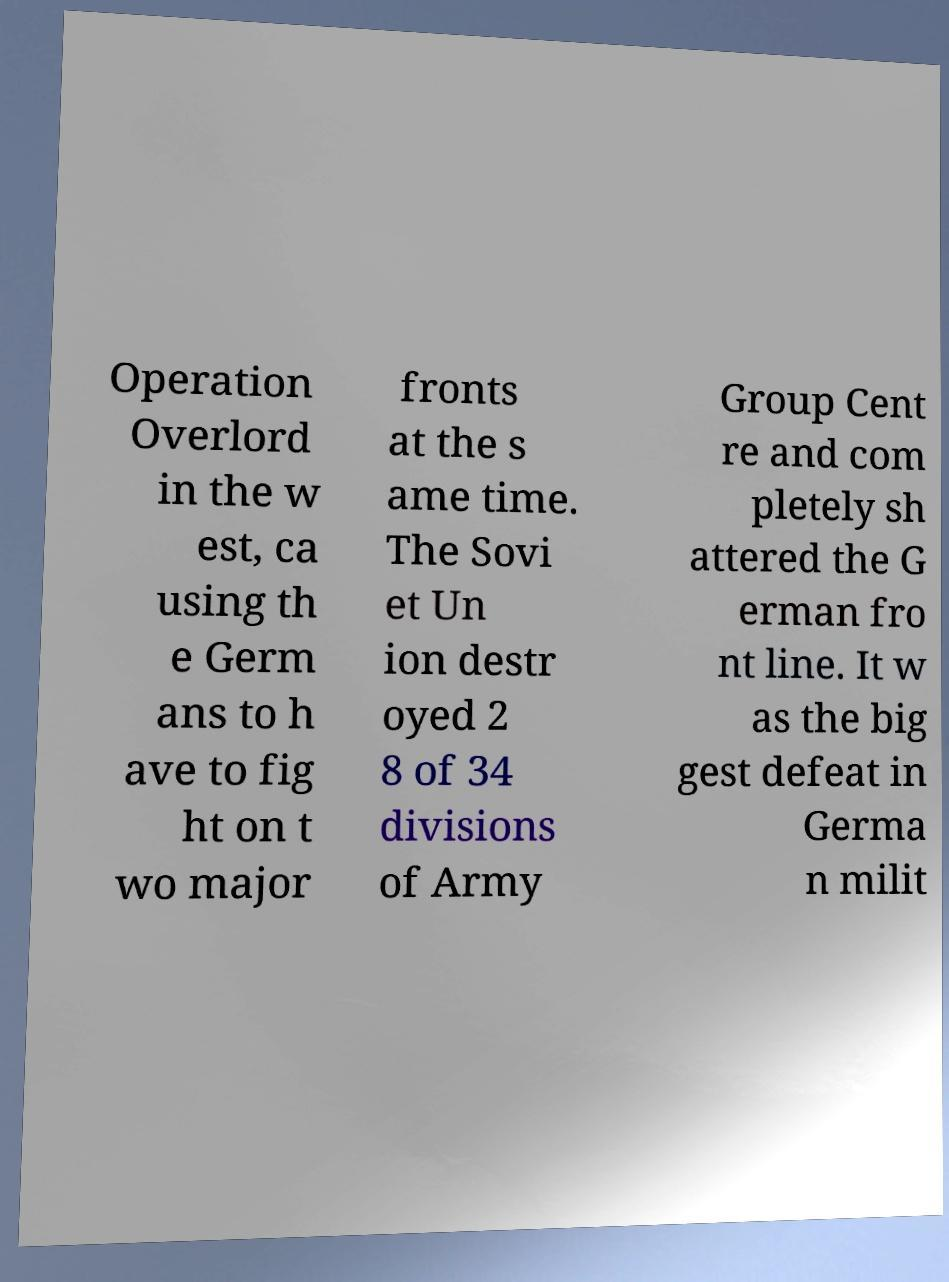Please read and relay the text visible in this image. What does it say? Operation Overlord in the w est, ca using th e Germ ans to h ave to fig ht on t wo major fronts at the s ame time. The Sovi et Un ion destr oyed 2 8 of 34 divisions of Army Group Cent re and com pletely sh attered the G erman fro nt line. It w as the big gest defeat in Germa n milit 